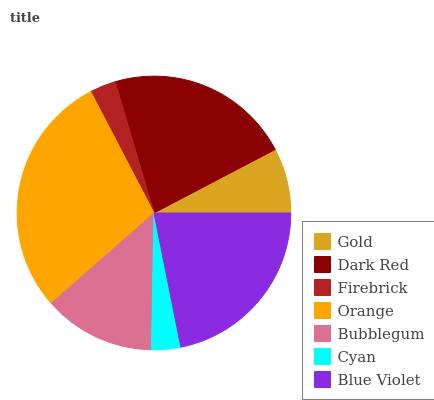Is Firebrick the minimum?
Answer yes or no. Yes. Is Orange the maximum?
Answer yes or no. Yes. Is Dark Red the minimum?
Answer yes or no. No. Is Dark Red the maximum?
Answer yes or no. No. Is Dark Red greater than Gold?
Answer yes or no. Yes. Is Gold less than Dark Red?
Answer yes or no. Yes. Is Gold greater than Dark Red?
Answer yes or no. No. Is Dark Red less than Gold?
Answer yes or no. No. Is Bubblegum the high median?
Answer yes or no. Yes. Is Bubblegum the low median?
Answer yes or no. Yes. Is Gold the high median?
Answer yes or no. No. Is Dark Red the low median?
Answer yes or no. No. 